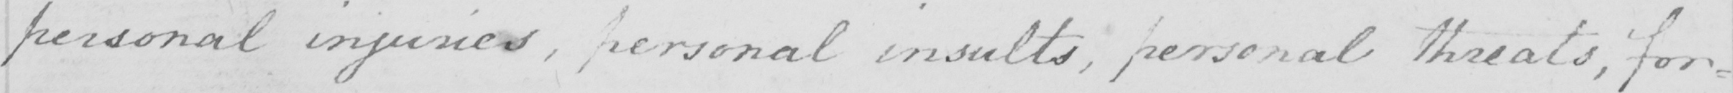Please transcribe the handwritten text in this image. personal injuries , personal insults , personal threats , for= 